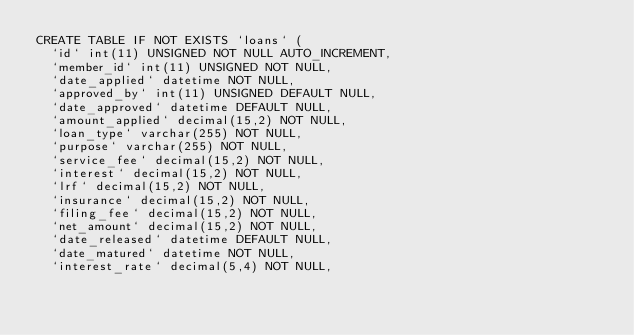Convert code to text. <code><loc_0><loc_0><loc_500><loc_500><_SQL_>CREATE TABLE IF NOT EXISTS `loans` (
  `id` int(11) UNSIGNED NOT NULL AUTO_INCREMENT,
  `member_id` int(11) UNSIGNED NOT NULL,
  `date_applied` datetime NOT NULL,
  `approved_by` int(11) UNSIGNED DEFAULT NULL,
  `date_approved` datetime DEFAULT NULL,
  `amount_applied` decimal(15,2) NOT NULL,
  `loan_type` varchar(255) NOT NULL,
  `purpose` varchar(255) NOT NULL,
  `service_fee` decimal(15,2) NOT NULL,
  `interest` decimal(15,2) NOT NULL,
  `lrf` decimal(15,2) NOT NULL,
  `insurance` decimal(15,2) NOT NULL,
  `filing_fee` decimal(15,2) NOT NULL,
  `net_amount` decimal(15,2) NOT NULL,
  `date_released` datetime DEFAULT NULL,
  `date_matured` datetime NOT NULL,
  `interest_rate` decimal(5,4) NOT NULL,</code> 